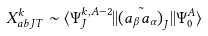<formula> <loc_0><loc_0><loc_500><loc_500>X ^ { k } _ { a b J T } \sim \langle \Psi ^ { k , A - 2 } _ { J } | | \tilde { ( a _ { \beta } a _ { \alpha } ) } _ { J } | | \Psi ^ { A } _ { 0 } \rangle</formula> 